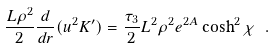<formula> <loc_0><loc_0><loc_500><loc_500>\frac { L \rho ^ { 2 } } { 2 } \frac { d } { d r } ( u ^ { 2 } K ^ { \prime } ) = \frac { \tau _ { 3 } } { 2 } L ^ { 2 } \rho ^ { 2 } e ^ { 2 A } \cosh ^ { 2 } \chi \ . \label l { e q \colon t o p r o v e }</formula> 